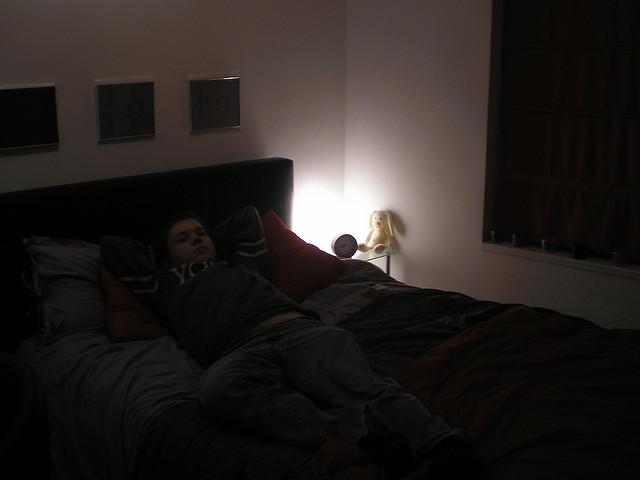The boy is most likely doing what? Please explain your reasoning. dreaming. The boy is in bed and the items associated with the other given options are not visible. 